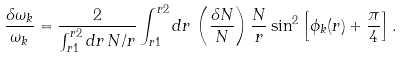<formula> <loc_0><loc_0><loc_500><loc_500>\frac { \delta \omega _ { k } } { \omega _ { k } } = \frac { 2 } { \int _ { r 1 } ^ { r 2 } d r \, N / r } \int _ { r 1 } ^ { r 2 } d r \, \left ( \frac { \delta N } { N } \right ) \frac { N } { r } \sin ^ { 2 } \left [ \phi _ { k } ( r ) + \frac { \pi } { 4 } \right ] .</formula> 